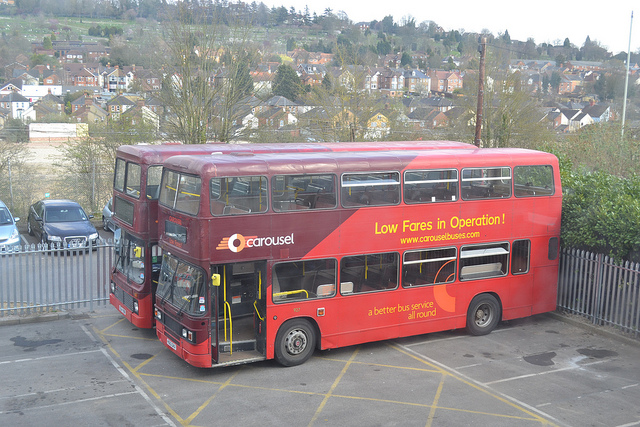Extract all visible text content from this image. LOW Fares Operation carousel in bus 